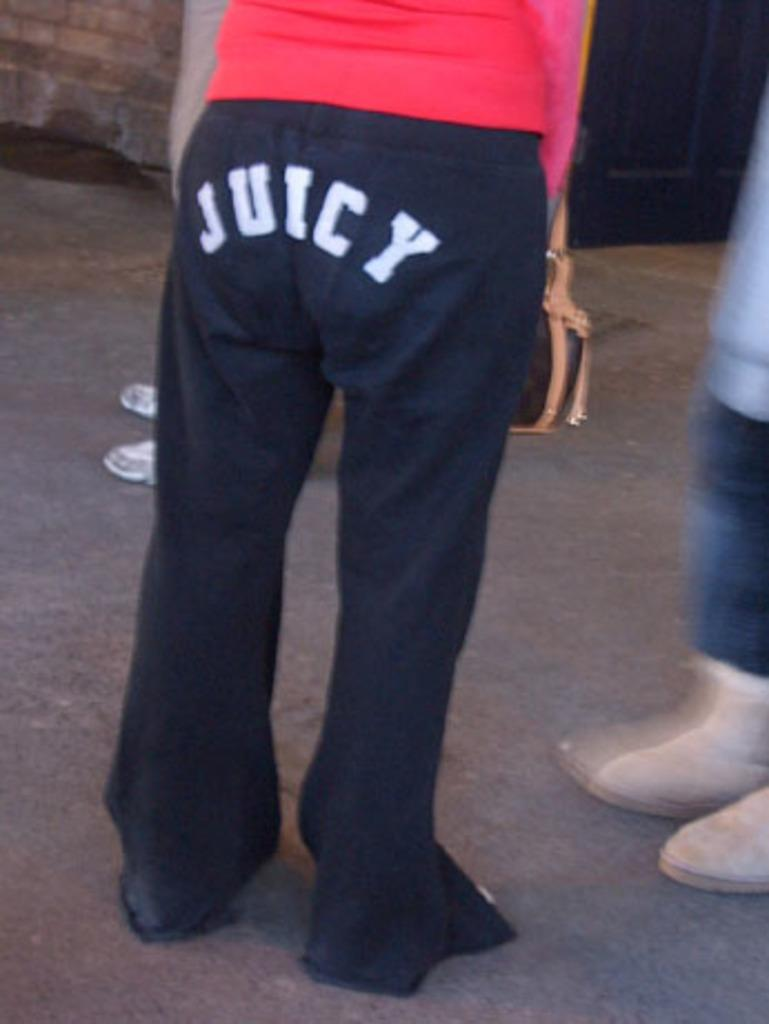<image>
Render a clear and concise summary of the photo. Woman wearing black pants that says the word JUICY on it. 